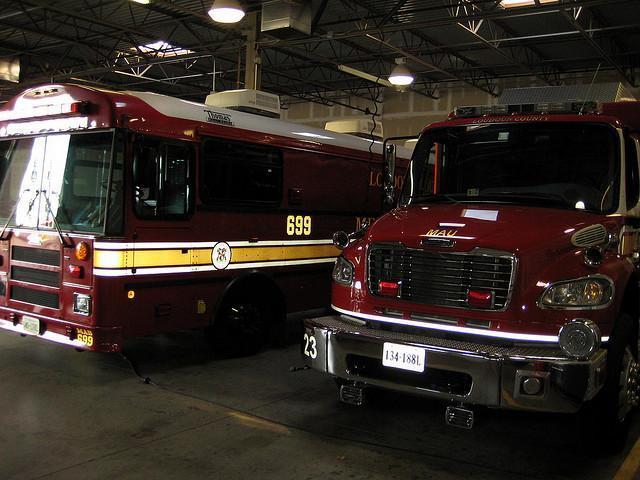How many person is wearing orange color t-shirt?
Give a very brief answer. 0. 